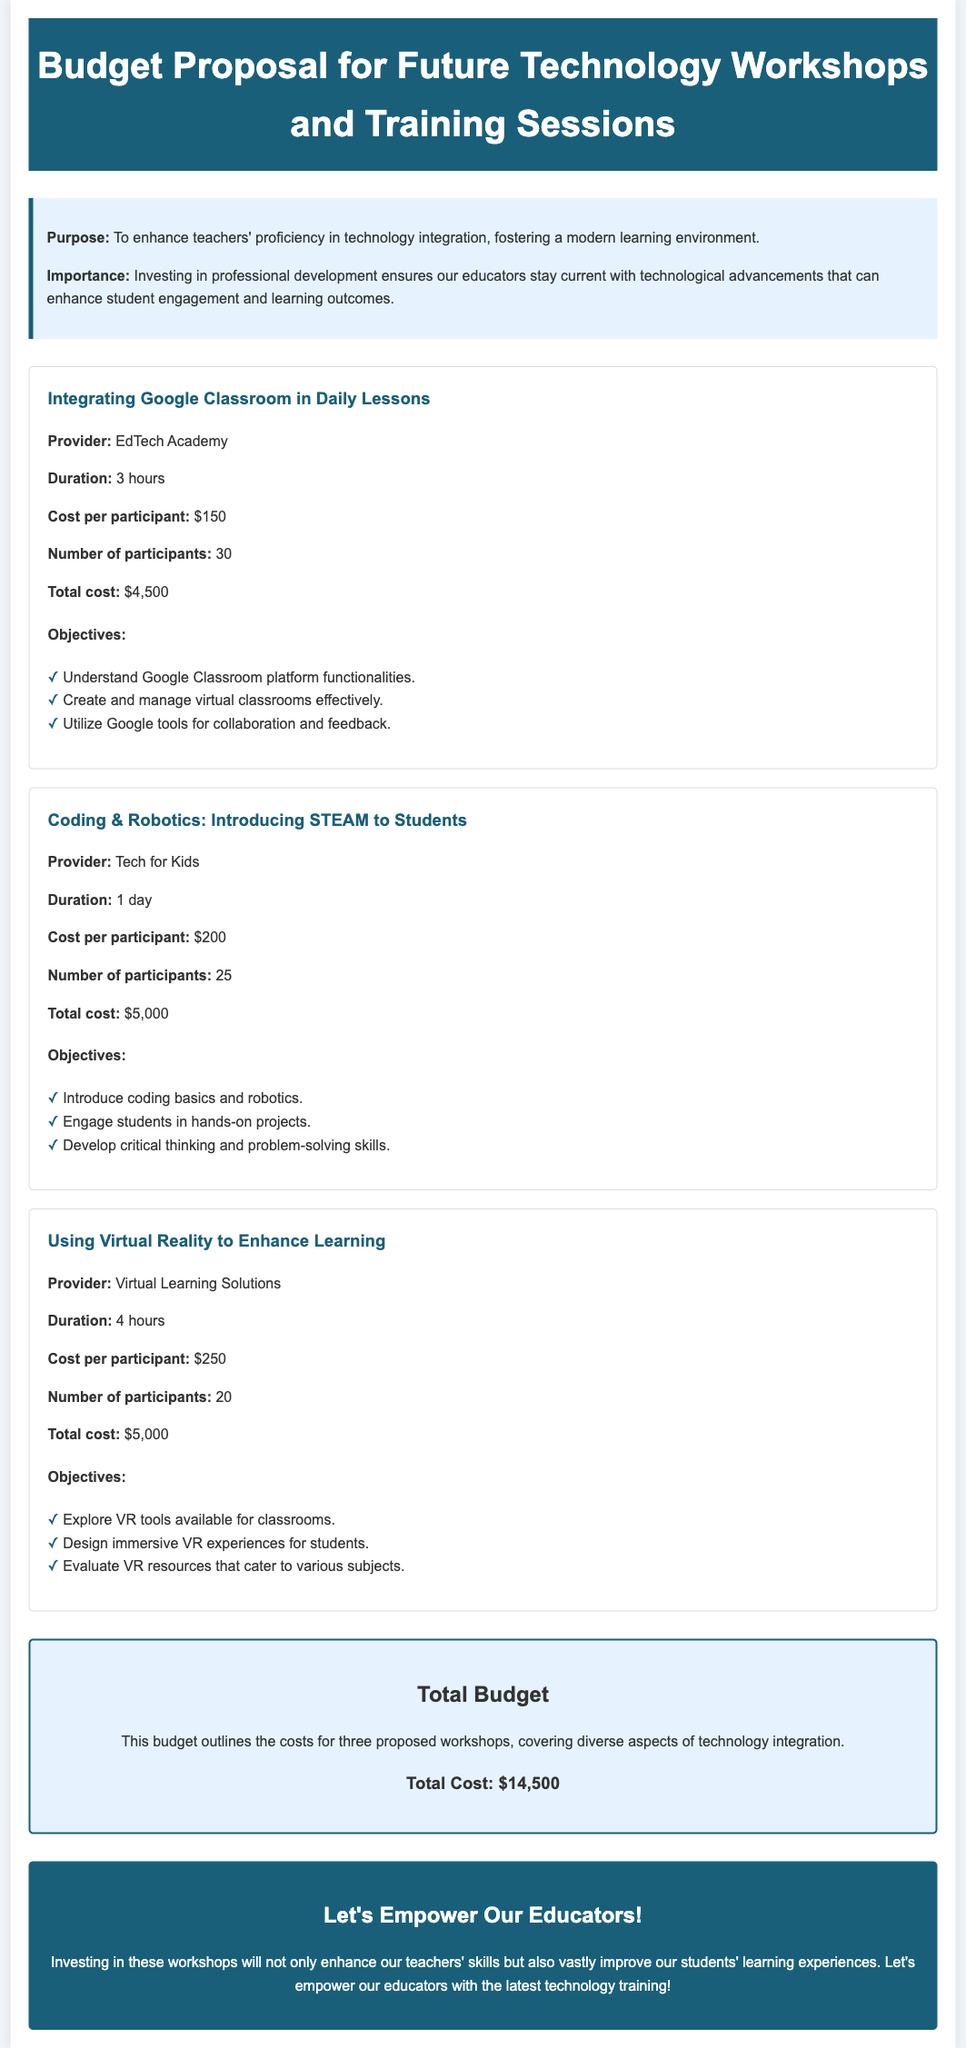What is the total budget for the workshops? The total budget is stated in the document as the sum of the costs for all proposed workshops, which is $14,500.
Answer: $14,500 Who is the provider for the workshop on using virtual reality? The document lists "Virtual Learning Solutions" as the provider for the virtual reality workshop.
Answer: Virtual Learning Solutions How long is the duration of the coding & robotics workshop? The document indicates that the coding & robotics workshop has a duration of 1 day.
Answer: 1 day What is the cost per participant for the workshop on integrating Google Classroom? The cost per participant for this workshop is specified in the document as $150.
Answer: $150 What is one of the objectives for the workshop on using virtual reality? The document provides various objectives, one of which is to "Explore VR tools available for classrooms."
Answer: Explore VR tools available for classrooms How many participants are expected for the Google Classroom workshop? The document states the number of participants for this workshop as 30.
Answer: 30 What is the total cost of the coding & robotics workshop? The document specifies the total cost of the coding & robotics workshop as $5,000.
Answer: $5,000 Which workshop focuses on integrating technology into daily lessons? The document mentions "Integrating Google Classroom in Daily Lessons" as the relevant workshop.
Answer: Integrating Google Classroom in Daily Lessons What is the main purpose of these workshops? The document outlines the main purpose as enhancing teachers' proficiency in technology integration.
Answer: Enhance teachers' proficiency in technology integration 